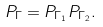<formula> <loc_0><loc_0><loc_500><loc_500>P _ { \Gamma } = P _ { \Gamma _ { 1 } } P _ { \Gamma _ { 2 } } .</formula> 